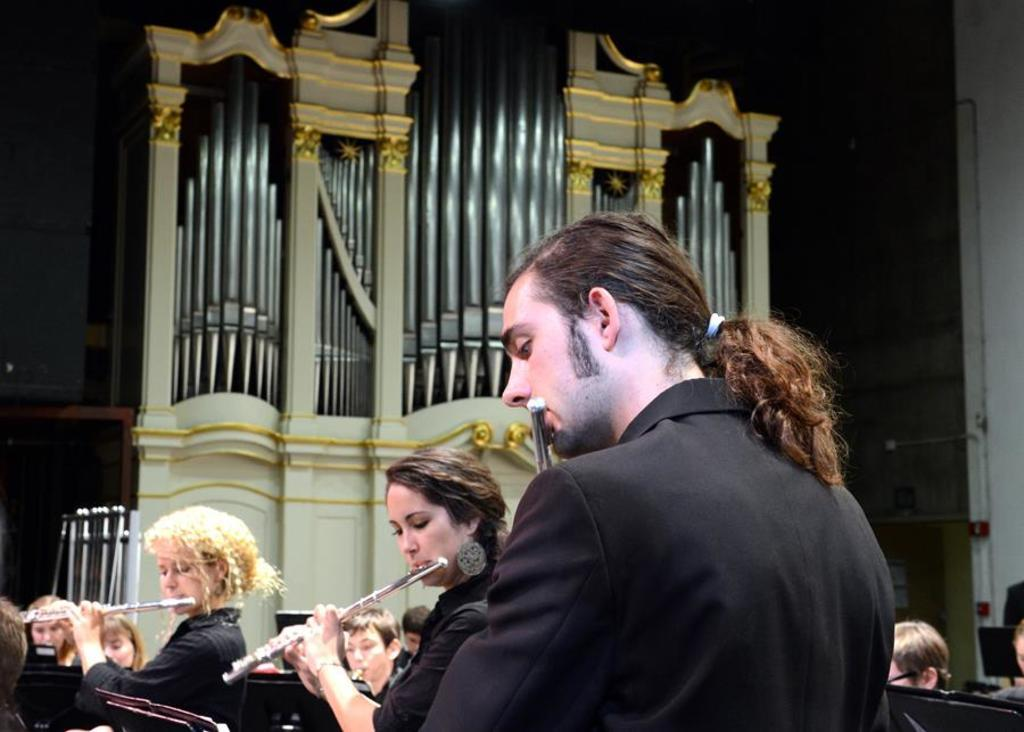How many people are the people are in the image? There are multiple people in the image. What are the people doing in the image? The people are holding musical instruments. Can you describe the background of the image? There is a design visible in the background of the image. Are there any firemen or jellyfish present in the image? No, there are no firemen or jellyfish present in the image. 